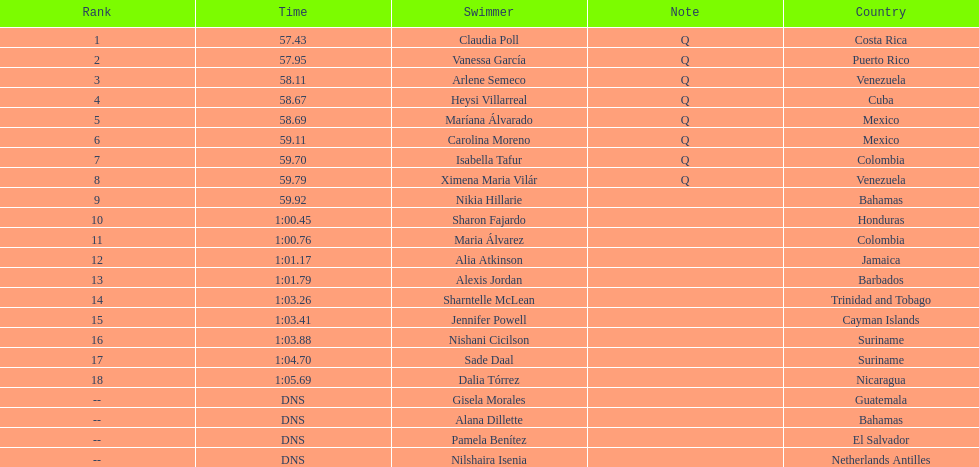Who was the only cuban to finish in the top eight? Heysi Villarreal. 